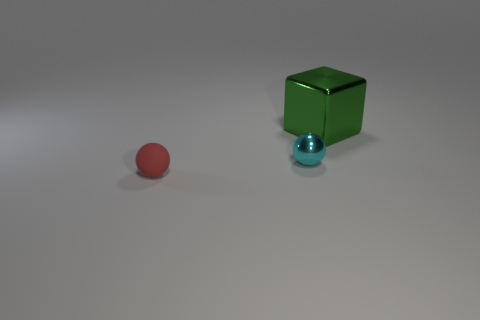There is a metal thing on the right side of the sphere that is behind the red ball; what color is it?
Ensure brevity in your answer.  Green. Are there any tiny rubber objects that have the same color as the metal sphere?
Ensure brevity in your answer.  No. What number of metal objects are big blocks or small cyan objects?
Provide a short and direct response. 2. Are there any other large green objects made of the same material as the large object?
Offer a terse response. No. How many objects are in front of the green shiny block and right of the red matte ball?
Your response must be concise. 1. Are there fewer small cyan things in front of the small cyan thing than tiny cyan objects left of the matte thing?
Your response must be concise. No. Is the shape of the big green thing the same as the small red matte object?
Your response must be concise. No. What number of other things are there of the same size as the red matte object?
Your answer should be compact. 1. What number of objects are either objects that are in front of the tiny cyan sphere or objects behind the red sphere?
Give a very brief answer. 3. How many small cyan metal objects are the same shape as the red thing?
Make the answer very short. 1. 